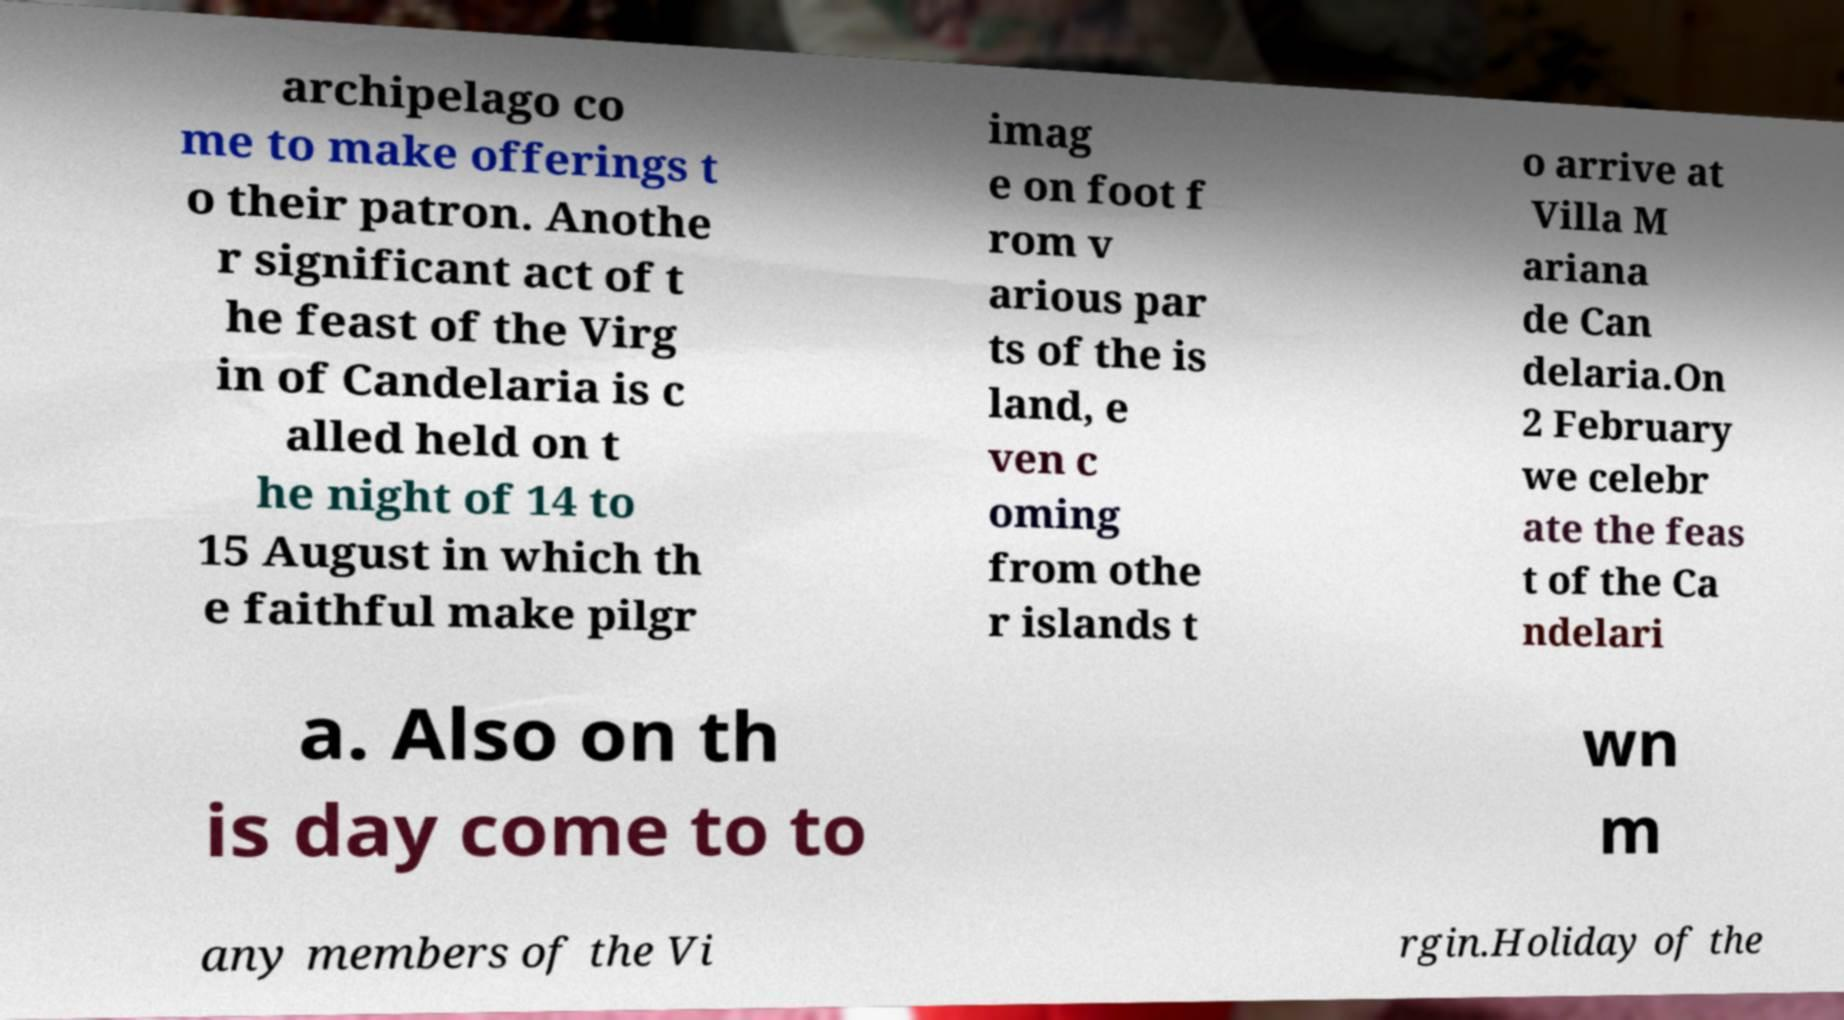Please read and relay the text visible in this image. What does it say? archipelago co me to make offerings t o their patron. Anothe r significant act of t he feast of the Virg in of Candelaria is c alled held on t he night of 14 to 15 August in which th e faithful make pilgr imag e on foot f rom v arious par ts of the is land, e ven c oming from othe r islands t o arrive at Villa M ariana de Can delaria.On 2 February we celebr ate the feas t of the Ca ndelari a. Also on th is day come to to wn m any members of the Vi rgin.Holiday of the 